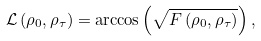Convert formula to latex. <formula><loc_0><loc_0><loc_500><loc_500>\mathcal { L } \left ( \rho _ { 0 } , \rho _ { \tau } \right ) = \arccos { \left ( \sqrt { F \left ( \rho _ { 0 } , \rho _ { \tau } \right ) } \right ) } \, ,</formula> 